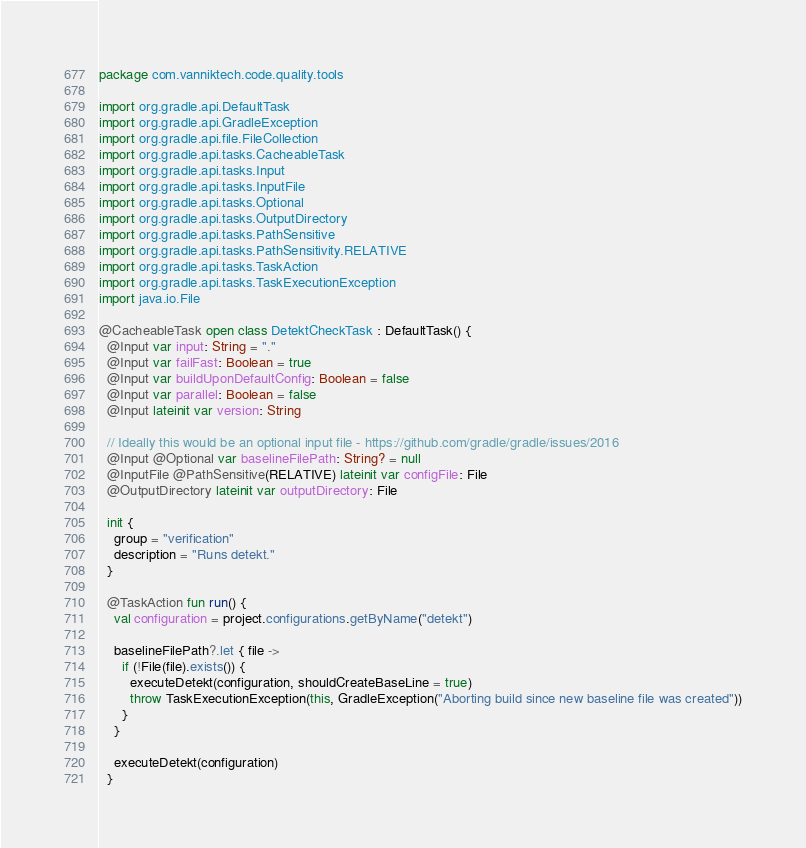<code> <loc_0><loc_0><loc_500><loc_500><_Kotlin_>package com.vanniktech.code.quality.tools

import org.gradle.api.DefaultTask
import org.gradle.api.GradleException
import org.gradle.api.file.FileCollection
import org.gradle.api.tasks.CacheableTask
import org.gradle.api.tasks.Input
import org.gradle.api.tasks.InputFile
import org.gradle.api.tasks.Optional
import org.gradle.api.tasks.OutputDirectory
import org.gradle.api.tasks.PathSensitive
import org.gradle.api.tasks.PathSensitivity.RELATIVE
import org.gradle.api.tasks.TaskAction
import org.gradle.api.tasks.TaskExecutionException
import java.io.File

@CacheableTask open class DetektCheckTask : DefaultTask() {
  @Input var input: String = "."
  @Input var failFast: Boolean = true
  @Input var buildUponDefaultConfig: Boolean = false
  @Input var parallel: Boolean = false
  @Input lateinit var version: String

  // Ideally this would be an optional input file - https://github.com/gradle/gradle/issues/2016
  @Input @Optional var baselineFilePath: String? = null
  @InputFile @PathSensitive(RELATIVE) lateinit var configFile: File
  @OutputDirectory lateinit var outputDirectory: File

  init {
    group = "verification"
    description = "Runs detekt."
  }

  @TaskAction fun run() {
    val configuration = project.configurations.getByName("detekt")

    baselineFilePath?.let { file ->
      if (!File(file).exists()) {
        executeDetekt(configuration, shouldCreateBaseLine = true)
        throw TaskExecutionException(this, GradleException("Aborting build since new baseline file was created"))
      }
    }

    executeDetekt(configuration)
  }
</code> 